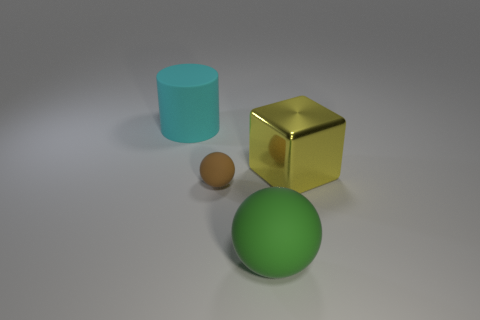Are there any other things that are the same size as the brown matte object?
Keep it short and to the point. No. The thing on the right side of the large matte thing in front of the large object that is to the right of the green rubber ball is what shape?
Keep it short and to the point. Cube. The other thing that is the same shape as the small brown matte thing is what color?
Your answer should be very brief. Green. What is the size of the thing that is both left of the big sphere and on the right side of the cyan cylinder?
Offer a terse response. Small. What number of big blocks are on the left side of the big rubber thing that is on the left side of the big matte object that is in front of the cyan rubber thing?
Offer a terse response. 0. How many tiny objects are blue blocks or yellow blocks?
Your answer should be very brief. 0. Is the material of the big object behind the metal object the same as the small brown thing?
Your answer should be very brief. Yes. There is a sphere behind the big rubber object that is in front of the big object that is behind the yellow metal block; what is its material?
Provide a succinct answer. Rubber. How many shiny things are tiny brown objects or yellow cubes?
Ensure brevity in your answer.  1. Is there a big green rubber thing?
Offer a terse response. Yes. 